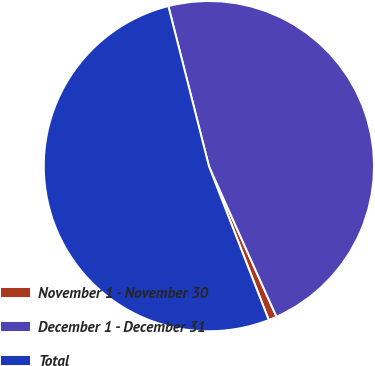<chart> <loc_0><loc_0><loc_500><loc_500><pie_chart><fcel>November 1 - November 30<fcel>December 1 - December 31<fcel>Total<nl><fcel>0.81%<fcel>47.23%<fcel>51.95%<nl></chart> 